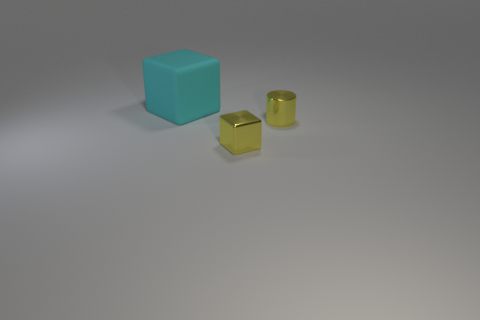Add 1 tiny yellow blocks. How many objects exist? 4 Subtract all blocks. How many objects are left? 1 Subtract all large cyan rubber things. Subtract all small yellow objects. How many objects are left? 0 Add 3 small yellow objects. How many small yellow objects are left? 5 Add 3 big cyan rubber cubes. How many big cyan rubber cubes exist? 4 Subtract 0 purple spheres. How many objects are left? 3 Subtract all red cylinders. Subtract all brown spheres. How many cylinders are left? 1 